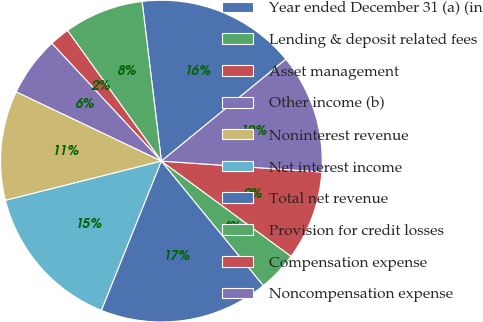Convert chart. <chart><loc_0><loc_0><loc_500><loc_500><pie_chart><fcel>Year ended December 31 (a) (in<fcel>Lending & deposit related fees<fcel>Asset management<fcel>Other income (b)<fcel>Noninterest revenue<fcel>Net interest income<fcel>Total net revenue<fcel>Provision for credit losses<fcel>Compensation expense<fcel>Noncompensation expense<nl><fcel>16.0%<fcel>8.0%<fcel>2.01%<fcel>6.0%<fcel>11.0%<fcel>15.0%<fcel>17.0%<fcel>4.0%<fcel>9.0%<fcel>12.0%<nl></chart> 